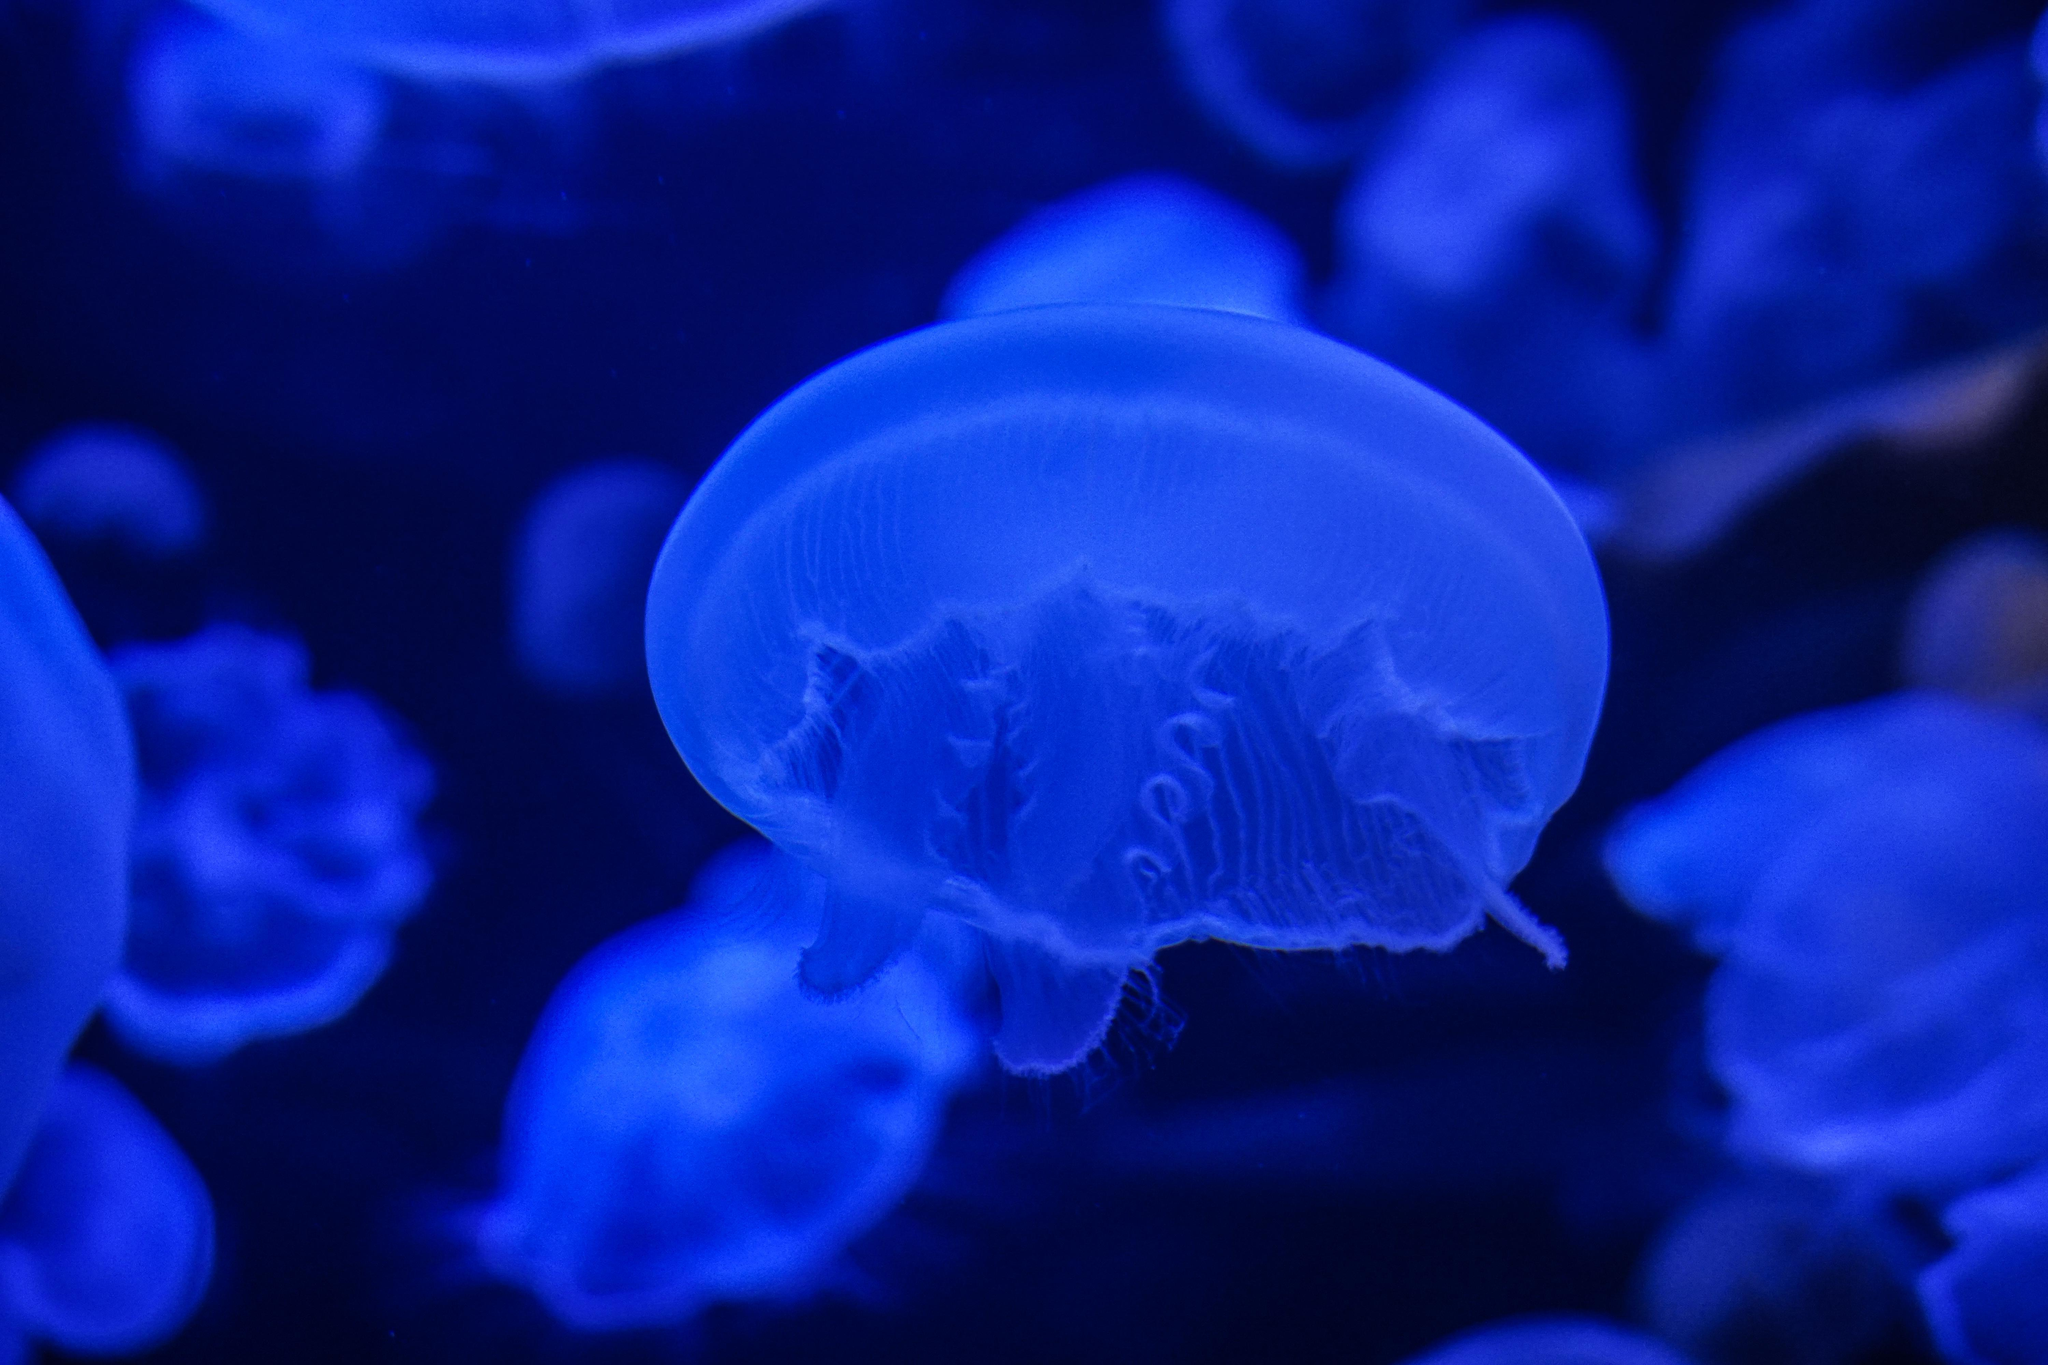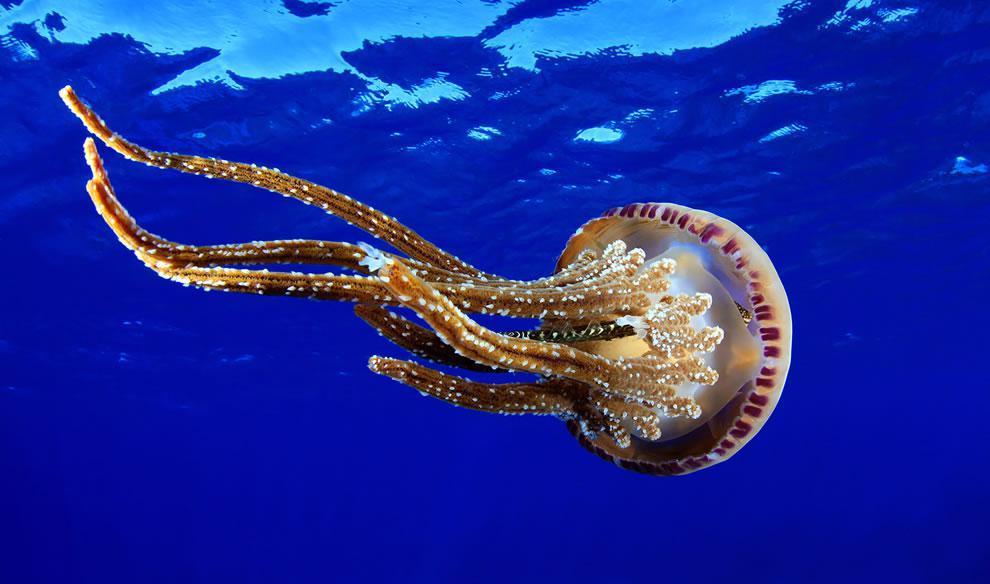The first image is the image on the left, the second image is the image on the right. Given the left and right images, does the statement "An image shows just one jellyfish, which has long, non-curly tendrils." hold true? Answer yes or no. Yes. The first image is the image on the left, the second image is the image on the right. For the images shown, is this caption "In one of the images, a single jellyfish floats on its side" true? Answer yes or no. Yes. 